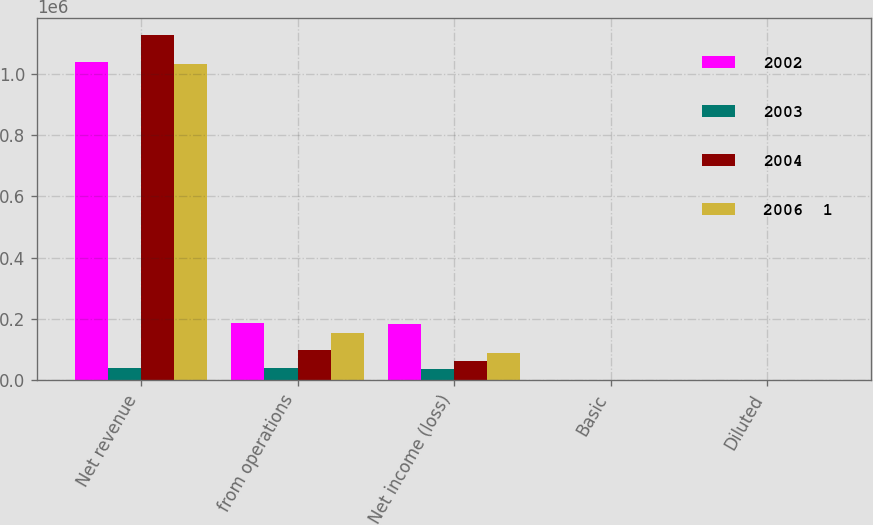Convert chart. <chart><loc_0><loc_0><loc_500><loc_500><stacked_bar_chart><ecel><fcel>Net revenue<fcel>from operations<fcel>Net income (loss)<fcel>Basic<fcel>Diluted<nl><fcel>2002<fcel>1.03784e+06<fcel>187166<fcel>184889<fcel>2.6<fcel>2.6<nl><fcel>2003<fcel>38018<fcel>38018<fcel>35314<fcel>0.51<fcel>0.5<nl><fcel>2004<fcel>1.12775e+06<fcel>97271<fcel>62119<fcel>0.93<fcel>0.91<nl><fcel>2006  1<fcel>1.03369e+06<fcel>152753<fcel>88672<fcel>1.41<fcel>1.37<nl></chart> 